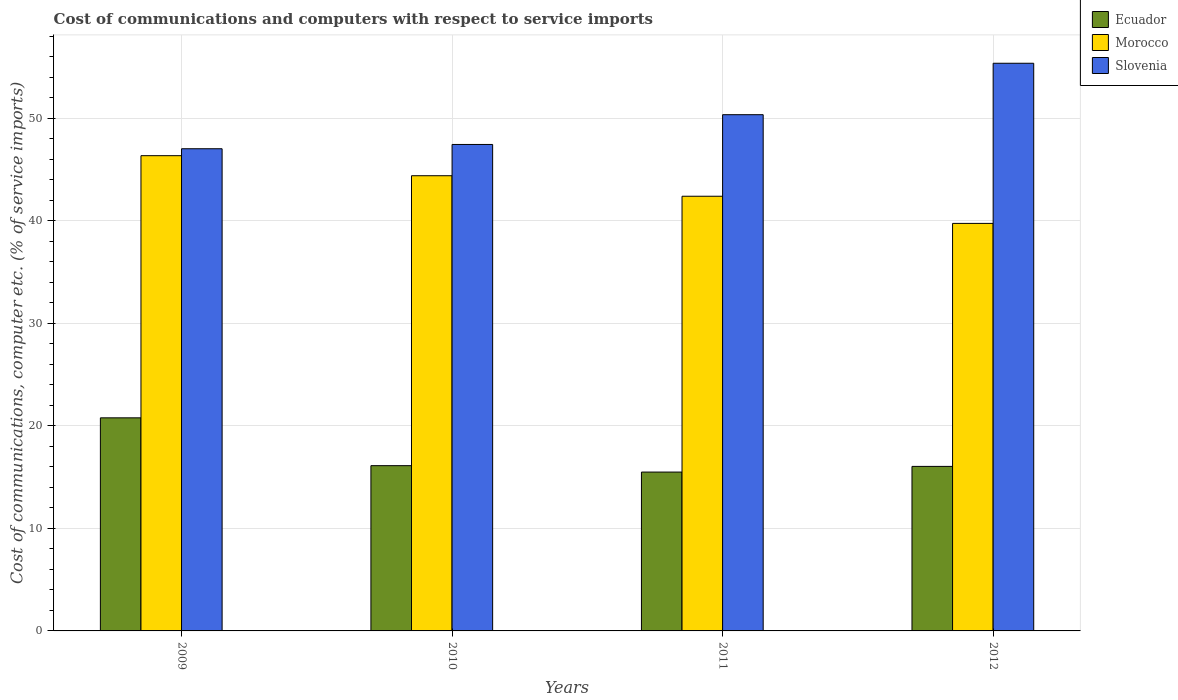How many groups of bars are there?
Give a very brief answer. 4. Are the number of bars per tick equal to the number of legend labels?
Offer a terse response. Yes. Are the number of bars on each tick of the X-axis equal?
Provide a short and direct response. Yes. How many bars are there on the 1st tick from the left?
Make the answer very short. 3. How many bars are there on the 4th tick from the right?
Provide a succinct answer. 3. In how many cases, is the number of bars for a given year not equal to the number of legend labels?
Keep it short and to the point. 0. What is the cost of communications and computers in Ecuador in 2011?
Your answer should be very brief. 15.49. Across all years, what is the maximum cost of communications and computers in Slovenia?
Provide a succinct answer. 55.37. Across all years, what is the minimum cost of communications and computers in Morocco?
Your answer should be very brief. 39.75. In which year was the cost of communications and computers in Slovenia minimum?
Provide a succinct answer. 2009. What is the total cost of communications and computers in Slovenia in the graph?
Your answer should be compact. 200.21. What is the difference between the cost of communications and computers in Ecuador in 2009 and that in 2011?
Give a very brief answer. 5.29. What is the difference between the cost of communications and computers in Slovenia in 2011 and the cost of communications and computers in Morocco in 2012?
Provide a short and direct response. 10.6. What is the average cost of communications and computers in Slovenia per year?
Keep it short and to the point. 50.05. In the year 2010, what is the difference between the cost of communications and computers in Morocco and cost of communications and computers in Ecuador?
Keep it short and to the point. 28.28. What is the ratio of the cost of communications and computers in Slovenia in 2010 to that in 2011?
Make the answer very short. 0.94. Is the cost of communications and computers in Morocco in 2009 less than that in 2010?
Your answer should be very brief. No. What is the difference between the highest and the second highest cost of communications and computers in Slovenia?
Your response must be concise. 5.02. What is the difference between the highest and the lowest cost of communications and computers in Slovenia?
Ensure brevity in your answer.  8.34. What does the 2nd bar from the left in 2011 represents?
Provide a short and direct response. Morocco. What does the 3rd bar from the right in 2009 represents?
Provide a short and direct response. Ecuador. Is it the case that in every year, the sum of the cost of communications and computers in Slovenia and cost of communications and computers in Ecuador is greater than the cost of communications and computers in Morocco?
Keep it short and to the point. Yes. Are all the bars in the graph horizontal?
Offer a very short reply. No. How many years are there in the graph?
Your response must be concise. 4. What is the difference between two consecutive major ticks on the Y-axis?
Your answer should be very brief. 10. Does the graph contain any zero values?
Your answer should be very brief. No. Does the graph contain grids?
Offer a very short reply. Yes. Where does the legend appear in the graph?
Your response must be concise. Top right. What is the title of the graph?
Keep it short and to the point. Cost of communications and computers with respect to service imports. Does "Burundi" appear as one of the legend labels in the graph?
Your response must be concise. No. What is the label or title of the Y-axis?
Your response must be concise. Cost of communications, computer etc. (% of service imports). What is the Cost of communications, computer etc. (% of service imports) in Ecuador in 2009?
Your answer should be compact. 20.79. What is the Cost of communications, computer etc. (% of service imports) in Morocco in 2009?
Offer a very short reply. 46.36. What is the Cost of communications, computer etc. (% of service imports) of Slovenia in 2009?
Provide a succinct answer. 47.03. What is the Cost of communications, computer etc. (% of service imports) in Ecuador in 2010?
Keep it short and to the point. 16.12. What is the Cost of communications, computer etc. (% of service imports) in Morocco in 2010?
Your response must be concise. 44.4. What is the Cost of communications, computer etc. (% of service imports) in Slovenia in 2010?
Provide a succinct answer. 47.45. What is the Cost of communications, computer etc. (% of service imports) of Ecuador in 2011?
Provide a short and direct response. 15.49. What is the Cost of communications, computer etc. (% of service imports) of Morocco in 2011?
Provide a succinct answer. 42.4. What is the Cost of communications, computer etc. (% of service imports) in Slovenia in 2011?
Provide a succinct answer. 50.35. What is the Cost of communications, computer etc. (% of service imports) of Ecuador in 2012?
Offer a very short reply. 16.05. What is the Cost of communications, computer etc. (% of service imports) of Morocco in 2012?
Ensure brevity in your answer.  39.75. What is the Cost of communications, computer etc. (% of service imports) in Slovenia in 2012?
Your answer should be very brief. 55.37. Across all years, what is the maximum Cost of communications, computer etc. (% of service imports) of Ecuador?
Give a very brief answer. 20.79. Across all years, what is the maximum Cost of communications, computer etc. (% of service imports) in Morocco?
Offer a terse response. 46.36. Across all years, what is the maximum Cost of communications, computer etc. (% of service imports) of Slovenia?
Provide a short and direct response. 55.37. Across all years, what is the minimum Cost of communications, computer etc. (% of service imports) of Ecuador?
Make the answer very short. 15.49. Across all years, what is the minimum Cost of communications, computer etc. (% of service imports) of Morocco?
Make the answer very short. 39.75. Across all years, what is the minimum Cost of communications, computer etc. (% of service imports) in Slovenia?
Your answer should be very brief. 47.03. What is the total Cost of communications, computer etc. (% of service imports) of Ecuador in the graph?
Provide a short and direct response. 68.45. What is the total Cost of communications, computer etc. (% of service imports) in Morocco in the graph?
Your response must be concise. 172.91. What is the total Cost of communications, computer etc. (% of service imports) in Slovenia in the graph?
Your answer should be very brief. 200.21. What is the difference between the Cost of communications, computer etc. (% of service imports) of Ecuador in 2009 and that in 2010?
Give a very brief answer. 4.67. What is the difference between the Cost of communications, computer etc. (% of service imports) of Morocco in 2009 and that in 2010?
Provide a short and direct response. 1.95. What is the difference between the Cost of communications, computer etc. (% of service imports) of Slovenia in 2009 and that in 2010?
Your answer should be very brief. -0.42. What is the difference between the Cost of communications, computer etc. (% of service imports) in Ecuador in 2009 and that in 2011?
Provide a short and direct response. 5.29. What is the difference between the Cost of communications, computer etc. (% of service imports) of Morocco in 2009 and that in 2011?
Your answer should be very brief. 3.96. What is the difference between the Cost of communications, computer etc. (% of service imports) in Slovenia in 2009 and that in 2011?
Your response must be concise. -3.32. What is the difference between the Cost of communications, computer etc. (% of service imports) of Ecuador in 2009 and that in 2012?
Ensure brevity in your answer.  4.74. What is the difference between the Cost of communications, computer etc. (% of service imports) in Morocco in 2009 and that in 2012?
Give a very brief answer. 6.6. What is the difference between the Cost of communications, computer etc. (% of service imports) of Slovenia in 2009 and that in 2012?
Provide a short and direct response. -8.34. What is the difference between the Cost of communications, computer etc. (% of service imports) in Ecuador in 2010 and that in 2011?
Your answer should be very brief. 0.62. What is the difference between the Cost of communications, computer etc. (% of service imports) of Morocco in 2010 and that in 2011?
Offer a very short reply. 2. What is the difference between the Cost of communications, computer etc. (% of service imports) of Slovenia in 2010 and that in 2011?
Offer a terse response. -2.9. What is the difference between the Cost of communications, computer etc. (% of service imports) of Ecuador in 2010 and that in 2012?
Provide a short and direct response. 0.07. What is the difference between the Cost of communications, computer etc. (% of service imports) in Morocco in 2010 and that in 2012?
Your answer should be compact. 4.65. What is the difference between the Cost of communications, computer etc. (% of service imports) of Slovenia in 2010 and that in 2012?
Give a very brief answer. -7.92. What is the difference between the Cost of communications, computer etc. (% of service imports) of Ecuador in 2011 and that in 2012?
Give a very brief answer. -0.55. What is the difference between the Cost of communications, computer etc. (% of service imports) of Morocco in 2011 and that in 2012?
Your response must be concise. 2.65. What is the difference between the Cost of communications, computer etc. (% of service imports) in Slovenia in 2011 and that in 2012?
Make the answer very short. -5.02. What is the difference between the Cost of communications, computer etc. (% of service imports) of Ecuador in 2009 and the Cost of communications, computer etc. (% of service imports) of Morocco in 2010?
Keep it short and to the point. -23.62. What is the difference between the Cost of communications, computer etc. (% of service imports) in Ecuador in 2009 and the Cost of communications, computer etc. (% of service imports) in Slovenia in 2010?
Provide a succinct answer. -26.67. What is the difference between the Cost of communications, computer etc. (% of service imports) of Morocco in 2009 and the Cost of communications, computer etc. (% of service imports) of Slovenia in 2010?
Your answer should be very brief. -1.09. What is the difference between the Cost of communications, computer etc. (% of service imports) of Ecuador in 2009 and the Cost of communications, computer etc. (% of service imports) of Morocco in 2011?
Provide a succinct answer. -21.62. What is the difference between the Cost of communications, computer etc. (% of service imports) of Ecuador in 2009 and the Cost of communications, computer etc. (% of service imports) of Slovenia in 2011?
Provide a succinct answer. -29.57. What is the difference between the Cost of communications, computer etc. (% of service imports) of Morocco in 2009 and the Cost of communications, computer etc. (% of service imports) of Slovenia in 2011?
Your response must be concise. -4. What is the difference between the Cost of communications, computer etc. (% of service imports) in Ecuador in 2009 and the Cost of communications, computer etc. (% of service imports) in Morocco in 2012?
Your answer should be compact. -18.97. What is the difference between the Cost of communications, computer etc. (% of service imports) in Ecuador in 2009 and the Cost of communications, computer etc. (% of service imports) in Slovenia in 2012?
Offer a terse response. -34.59. What is the difference between the Cost of communications, computer etc. (% of service imports) of Morocco in 2009 and the Cost of communications, computer etc. (% of service imports) of Slovenia in 2012?
Make the answer very short. -9.02. What is the difference between the Cost of communications, computer etc. (% of service imports) in Ecuador in 2010 and the Cost of communications, computer etc. (% of service imports) in Morocco in 2011?
Give a very brief answer. -26.28. What is the difference between the Cost of communications, computer etc. (% of service imports) of Ecuador in 2010 and the Cost of communications, computer etc. (% of service imports) of Slovenia in 2011?
Provide a succinct answer. -34.23. What is the difference between the Cost of communications, computer etc. (% of service imports) of Morocco in 2010 and the Cost of communications, computer etc. (% of service imports) of Slovenia in 2011?
Offer a terse response. -5.95. What is the difference between the Cost of communications, computer etc. (% of service imports) in Ecuador in 2010 and the Cost of communications, computer etc. (% of service imports) in Morocco in 2012?
Provide a short and direct response. -23.63. What is the difference between the Cost of communications, computer etc. (% of service imports) of Ecuador in 2010 and the Cost of communications, computer etc. (% of service imports) of Slovenia in 2012?
Provide a short and direct response. -39.25. What is the difference between the Cost of communications, computer etc. (% of service imports) of Morocco in 2010 and the Cost of communications, computer etc. (% of service imports) of Slovenia in 2012?
Make the answer very short. -10.97. What is the difference between the Cost of communications, computer etc. (% of service imports) of Ecuador in 2011 and the Cost of communications, computer etc. (% of service imports) of Morocco in 2012?
Your answer should be very brief. -24.26. What is the difference between the Cost of communications, computer etc. (% of service imports) of Ecuador in 2011 and the Cost of communications, computer etc. (% of service imports) of Slovenia in 2012?
Provide a short and direct response. -39.88. What is the difference between the Cost of communications, computer etc. (% of service imports) in Morocco in 2011 and the Cost of communications, computer etc. (% of service imports) in Slovenia in 2012?
Make the answer very short. -12.97. What is the average Cost of communications, computer etc. (% of service imports) in Ecuador per year?
Your response must be concise. 17.11. What is the average Cost of communications, computer etc. (% of service imports) of Morocco per year?
Your answer should be very brief. 43.23. What is the average Cost of communications, computer etc. (% of service imports) of Slovenia per year?
Your answer should be very brief. 50.05. In the year 2009, what is the difference between the Cost of communications, computer etc. (% of service imports) in Ecuador and Cost of communications, computer etc. (% of service imports) in Morocco?
Provide a short and direct response. -25.57. In the year 2009, what is the difference between the Cost of communications, computer etc. (% of service imports) in Ecuador and Cost of communications, computer etc. (% of service imports) in Slovenia?
Make the answer very short. -26.25. In the year 2009, what is the difference between the Cost of communications, computer etc. (% of service imports) of Morocco and Cost of communications, computer etc. (% of service imports) of Slovenia?
Give a very brief answer. -0.68. In the year 2010, what is the difference between the Cost of communications, computer etc. (% of service imports) in Ecuador and Cost of communications, computer etc. (% of service imports) in Morocco?
Keep it short and to the point. -28.28. In the year 2010, what is the difference between the Cost of communications, computer etc. (% of service imports) of Ecuador and Cost of communications, computer etc. (% of service imports) of Slovenia?
Provide a short and direct response. -31.33. In the year 2010, what is the difference between the Cost of communications, computer etc. (% of service imports) of Morocco and Cost of communications, computer etc. (% of service imports) of Slovenia?
Your response must be concise. -3.05. In the year 2011, what is the difference between the Cost of communications, computer etc. (% of service imports) in Ecuador and Cost of communications, computer etc. (% of service imports) in Morocco?
Keep it short and to the point. -26.91. In the year 2011, what is the difference between the Cost of communications, computer etc. (% of service imports) in Ecuador and Cost of communications, computer etc. (% of service imports) in Slovenia?
Offer a very short reply. -34.86. In the year 2011, what is the difference between the Cost of communications, computer etc. (% of service imports) in Morocco and Cost of communications, computer etc. (% of service imports) in Slovenia?
Provide a short and direct response. -7.95. In the year 2012, what is the difference between the Cost of communications, computer etc. (% of service imports) in Ecuador and Cost of communications, computer etc. (% of service imports) in Morocco?
Ensure brevity in your answer.  -23.7. In the year 2012, what is the difference between the Cost of communications, computer etc. (% of service imports) in Ecuador and Cost of communications, computer etc. (% of service imports) in Slovenia?
Make the answer very short. -39.32. In the year 2012, what is the difference between the Cost of communications, computer etc. (% of service imports) in Morocco and Cost of communications, computer etc. (% of service imports) in Slovenia?
Offer a very short reply. -15.62. What is the ratio of the Cost of communications, computer etc. (% of service imports) of Ecuador in 2009 to that in 2010?
Ensure brevity in your answer.  1.29. What is the ratio of the Cost of communications, computer etc. (% of service imports) in Morocco in 2009 to that in 2010?
Provide a short and direct response. 1.04. What is the ratio of the Cost of communications, computer etc. (% of service imports) of Ecuador in 2009 to that in 2011?
Ensure brevity in your answer.  1.34. What is the ratio of the Cost of communications, computer etc. (% of service imports) of Morocco in 2009 to that in 2011?
Provide a succinct answer. 1.09. What is the ratio of the Cost of communications, computer etc. (% of service imports) of Slovenia in 2009 to that in 2011?
Make the answer very short. 0.93. What is the ratio of the Cost of communications, computer etc. (% of service imports) of Ecuador in 2009 to that in 2012?
Offer a terse response. 1.3. What is the ratio of the Cost of communications, computer etc. (% of service imports) in Morocco in 2009 to that in 2012?
Your answer should be compact. 1.17. What is the ratio of the Cost of communications, computer etc. (% of service imports) in Slovenia in 2009 to that in 2012?
Provide a short and direct response. 0.85. What is the ratio of the Cost of communications, computer etc. (% of service imports) of Ecuador in 2010 to that in 2011?
Your answer should be compact. 1.04. What is the ratio of the Cost of communications, computer etc. (% of service imports) in Morocco in 2010 to that in 2011?
Ensure brevity in your answer.  1.05. What is the ratio of the Cost of communications, computer etc. (% of service imports) in Slovenia in 2010 to that in 2011?
Your response must be concise. 0.94. What is the ratio of the Cost of communications, computer etc. (% of service imports) of Ecuador in 2010 to that in 2012?
Your response must be concise. 1. What is the ratio of the Cost of communications, computer etc. (% of service imports) in Morocco in 2010 to that in 2012?
Make the answer very short. 1.12. What is the ratio of the Cost of communications, computer etc. (% of service imports) of Slovenia in 2010 to that in 2012?
Keep it short and to the point. 0.86. What is the ratio of the Cost of communications, computer etc. (% of service imports) in Ecuador in 2011 to that in 2012?
Your answer should be compact. 0.97. What is the ratio of the Cost of communications, computer etc. (% of service imports) of Morocco in 2011 to that in 2012?
Make the answer very short. 1.07. What is the ratio of the Cost of communications, computer etc. (% of service imports) in Slovenia in 2011 to that in 2012?
Offer a terse response. 0.91. What is the difference between the highest and the second highest Cost of communications, computer etc. (% of service imports) of Ecuador?
Offer a very short reply. 4.67. What is the difference between the highest and the second highest Cost of communications, computer etc. (% of service imports) in Morocco?
Offer a terse response. 1.95. What is the difference between the highest and the second highest Cost of communications, computer etc. (% of service imports) of Slovenia?
Provide a short and direct response. 5.02. What is the difference between the highest and the lowest Cost of communications, computer etc. (% of service imports) of Ecuador?
Ensure brevity in your answer.  5.29. What is the difference between the highest and the lowest Cost of communications, computer etc. (% of service imports) in Morocco?
Provide a succinct answer. 6.6. What is the difference between the highest and the lowest Cost of communications, computer etc. (% of service imports) in Slovenia?
Provide a succinct answer. 8.34. 